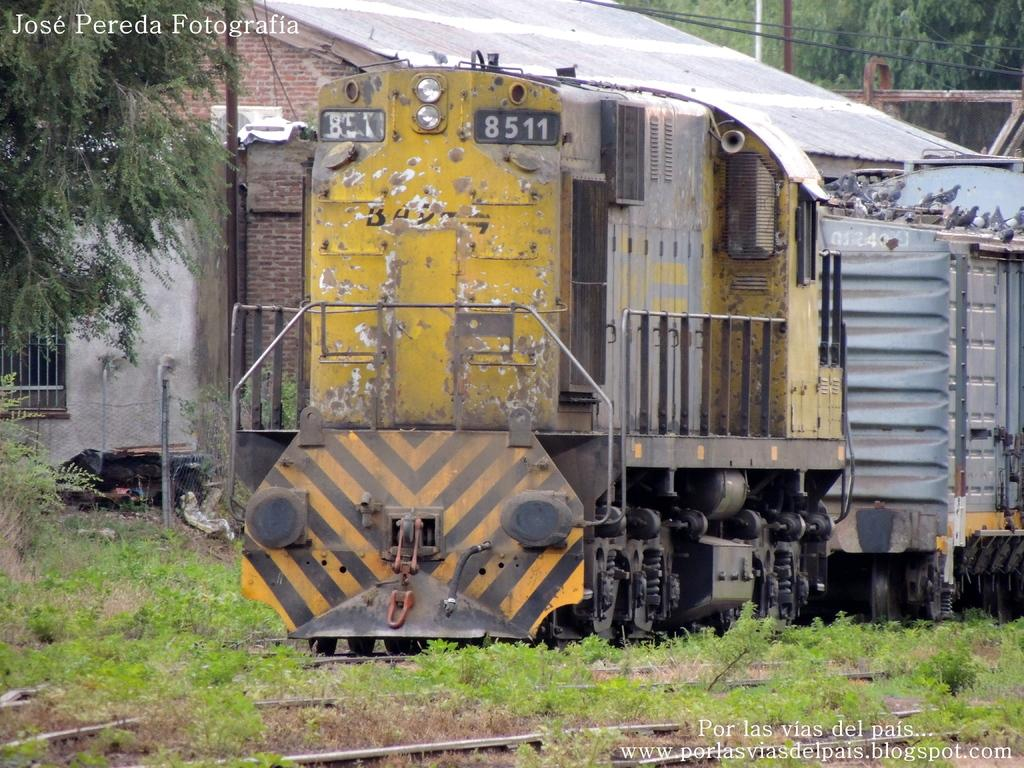What is the main subject in the foreground of the image? There is a train in the foreground of the image. What type of terrain is visible at the bottom side of the image? Grassland is present at the bottom side of the image. What can be seen in the background of the image? There are trees and poles in the background of the image, as well as the sky. Is there any text present in the image? Yes, there is text at the top side of the image. What type of cherry is hanging from the poles in the background of the image? There are no cherries present in the image; the poles are not associated with any fruit. What type of silk is draped over the train in the image? There is no silk present in the image; the train is not draped with any fabric. 